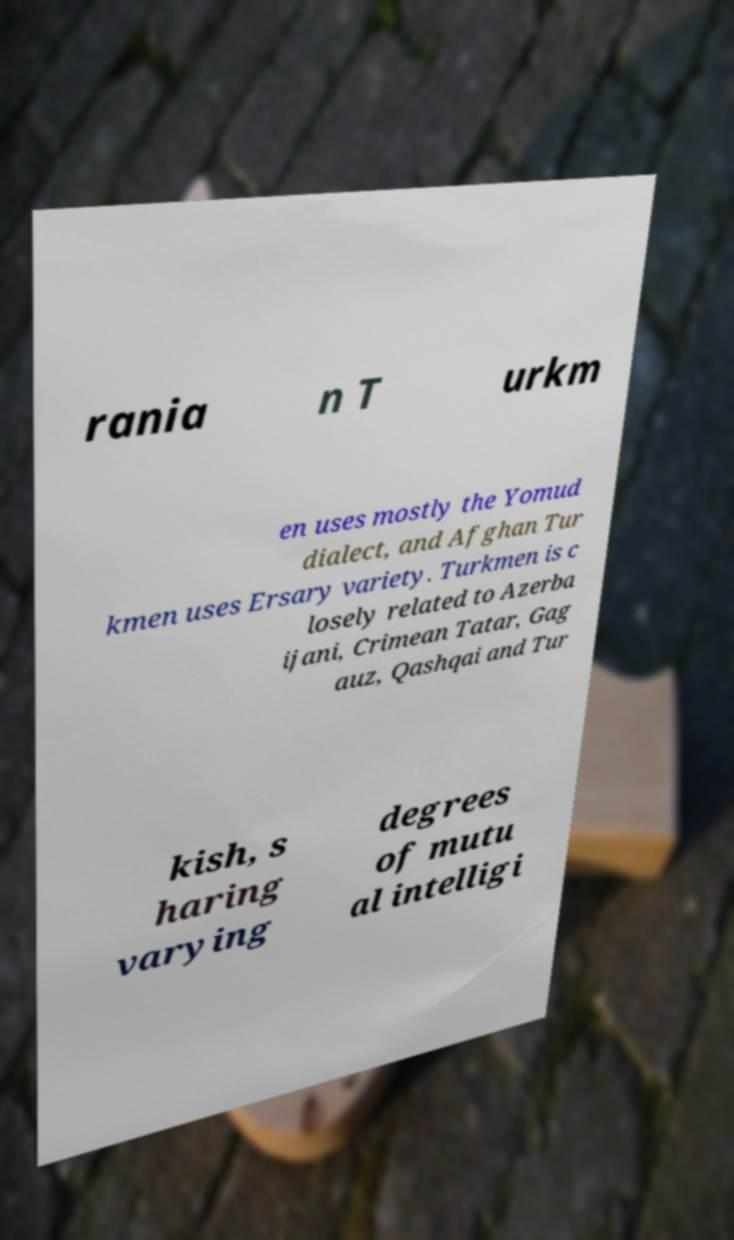Can you read and provide the text displayed in the image?This photo seems to have some interesting text. Can you extract and type it out for me? rania n T urkm en uses mostly the Yomud dialect, and Afghan Tur kmen uses Ersary variety. Turkmen is c losely related to Azerba ijani, Crimean Tatar, Gag auz, Qashqai and Tur kish, s haring varying degrees of mutu al intelligi 